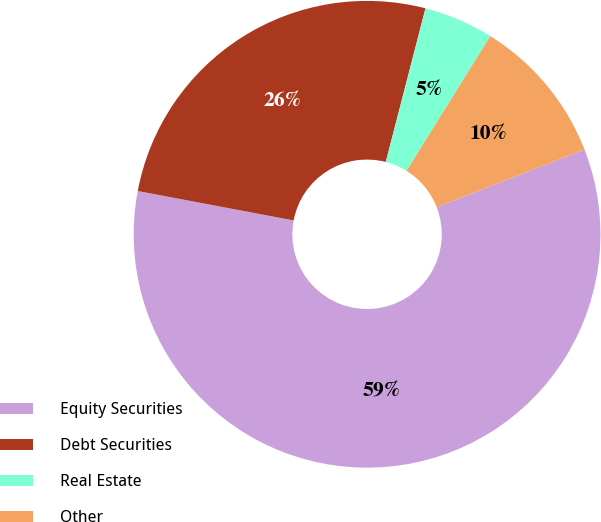Convert chart to OTSL. <chart><loc_0><loc_0><loc_500><loc_500><pie_chart><fcel>Equity Securities<fcel>Debt Securities<fcel>Real Estate<fcel>Other<nl><fcel>58.88%<fcel>26.06%<fcel>4.83%<fcel>10.23%<nl></chart> 